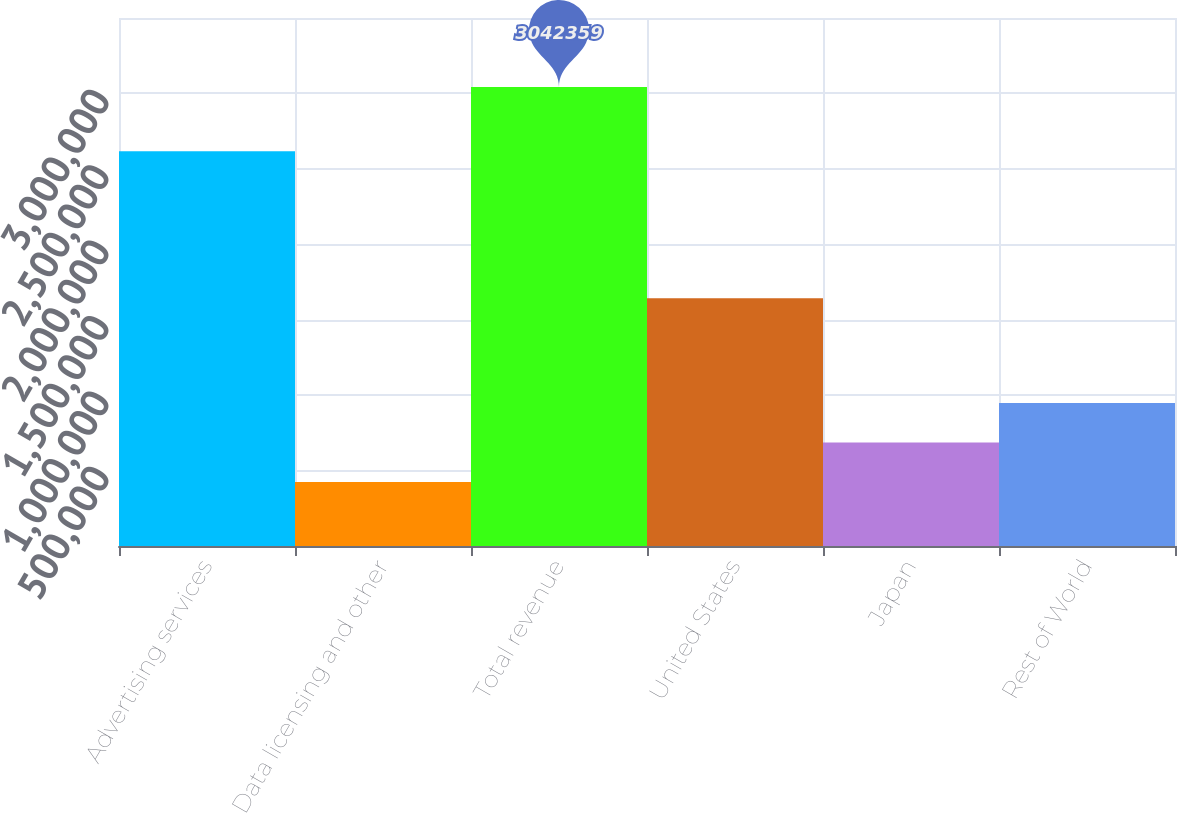<chart> <loc_0><loc_0><loc_500><loc_500><bar_chart><fcel>Advertising services<fcel>Data licensing and other<fcel>Total revenue<fcel>United States<fcel>Japan<fcel>Rest of World<nl><fcel>2.6174e+06<fcel>424962<fcel>3.04236e+06<fcel>1.64226e+06<fcel>686702<fcel>948441<nl></chart> 